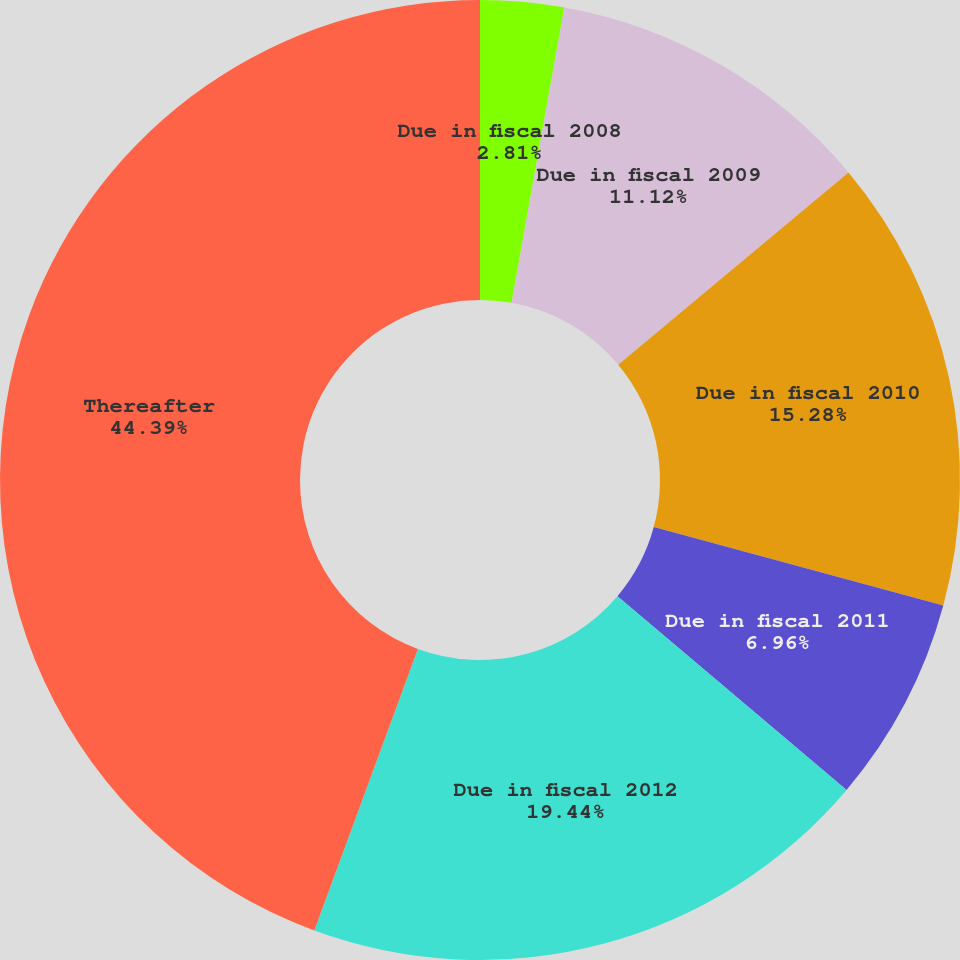Convert chart to OTSL. <chart><loc_0><loc_0><loc_500><loc_500><pie_chart><fcel>Due in fiscal 2008<fcel>Due in fiscal 2009<fcel>Due in fiscal 2010<fcel>Due in fiscal 2011<fcel>Due in fiscal 2012<fcel>Thereafter<nl><fcel>2.81%<fcel>11.12%<fcel>15.28%<fcel>6.96%<fcel>19.44%<fcel>44.39%<nl></chart> 